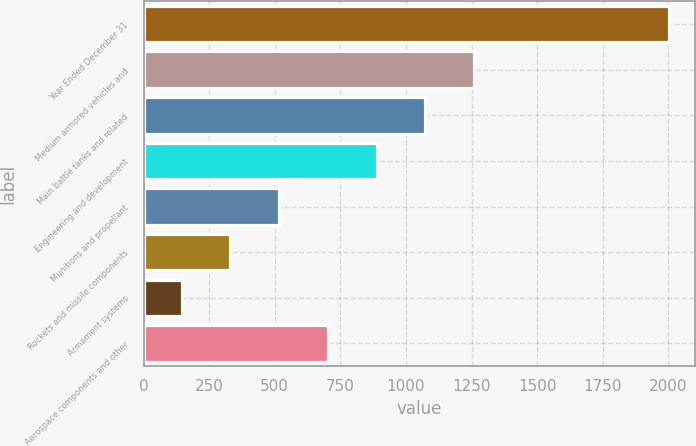Convert chart. <chart><loc_0><loc_0><loc_500><loc_500><bar_chart><fcel>Year Ended December 31<fcel>Medium armored vehicles and<fcel>Main battle tanks and related<fcel>Engineering and development<fcel>Munitions and propellant<fcel>Rockets and missile components<fcel>Armament systems<fcel>Aerospace components and other<nl><fcel>2003<fcel>1259.8<fcel>1074<fcel>888.2<fcel>516.6<fcel>330.8<fcel>145<fcel>702.4<nl></chart> 